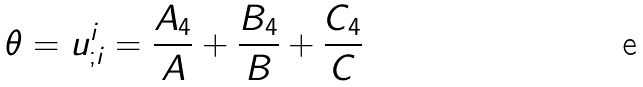Convert formula to latex. <formula><loc_0><loc_0><loc_500><loc_500>\theta = u ^ { i } _ { ; i } = \frac { A _ { 4 } } { A } + \frac { B _ { 4 } } { B } + \frac { C _ { 4 } } { C }</formula> 